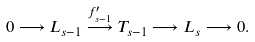Convert formula to latex. <formula><loc_0><loc_0><loc_500><loc_500>0 \longrightarrow L _ { s - 1 } \stackrel { f ^ { \prime } _ { s - 1 } } { \longrightarrow } T _ { s - 1 } \longrightarrow L _ { s } \longrightarrow 0 .</formula> 